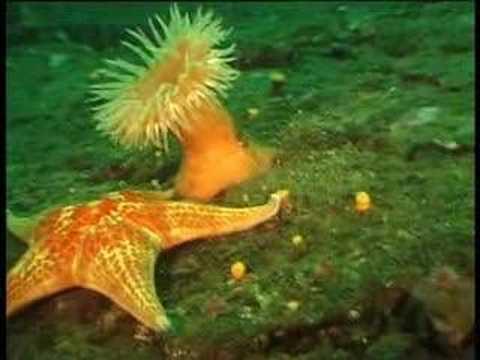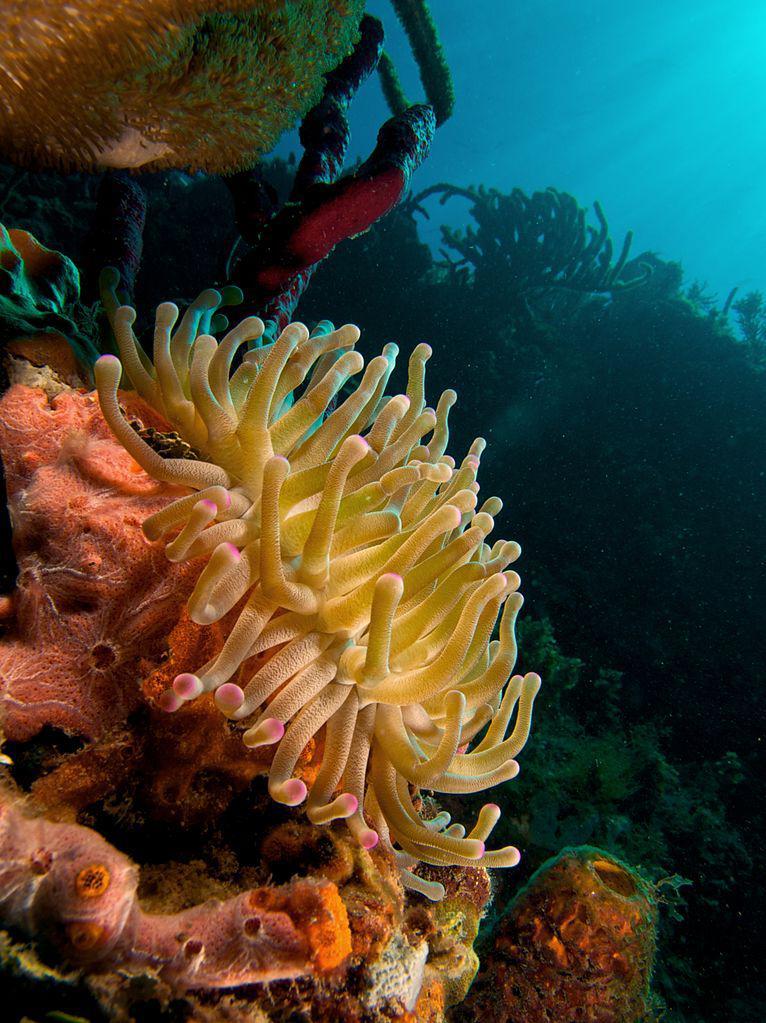The first image is the image on the left, the second image is the image on the right. For the images shown, is this caption "The right image features at least one clown fish swimming in front of anemone tendrils, and the left image includes at least one anemone with tapering tendrils and an orange stalk." true? Answer yes or no. No. The first image is the image on the left, the second image is the image on the right. Given the left and right images, does the statement "The right image contains at least two clown fish." hold true? Answer yes or no. No. 